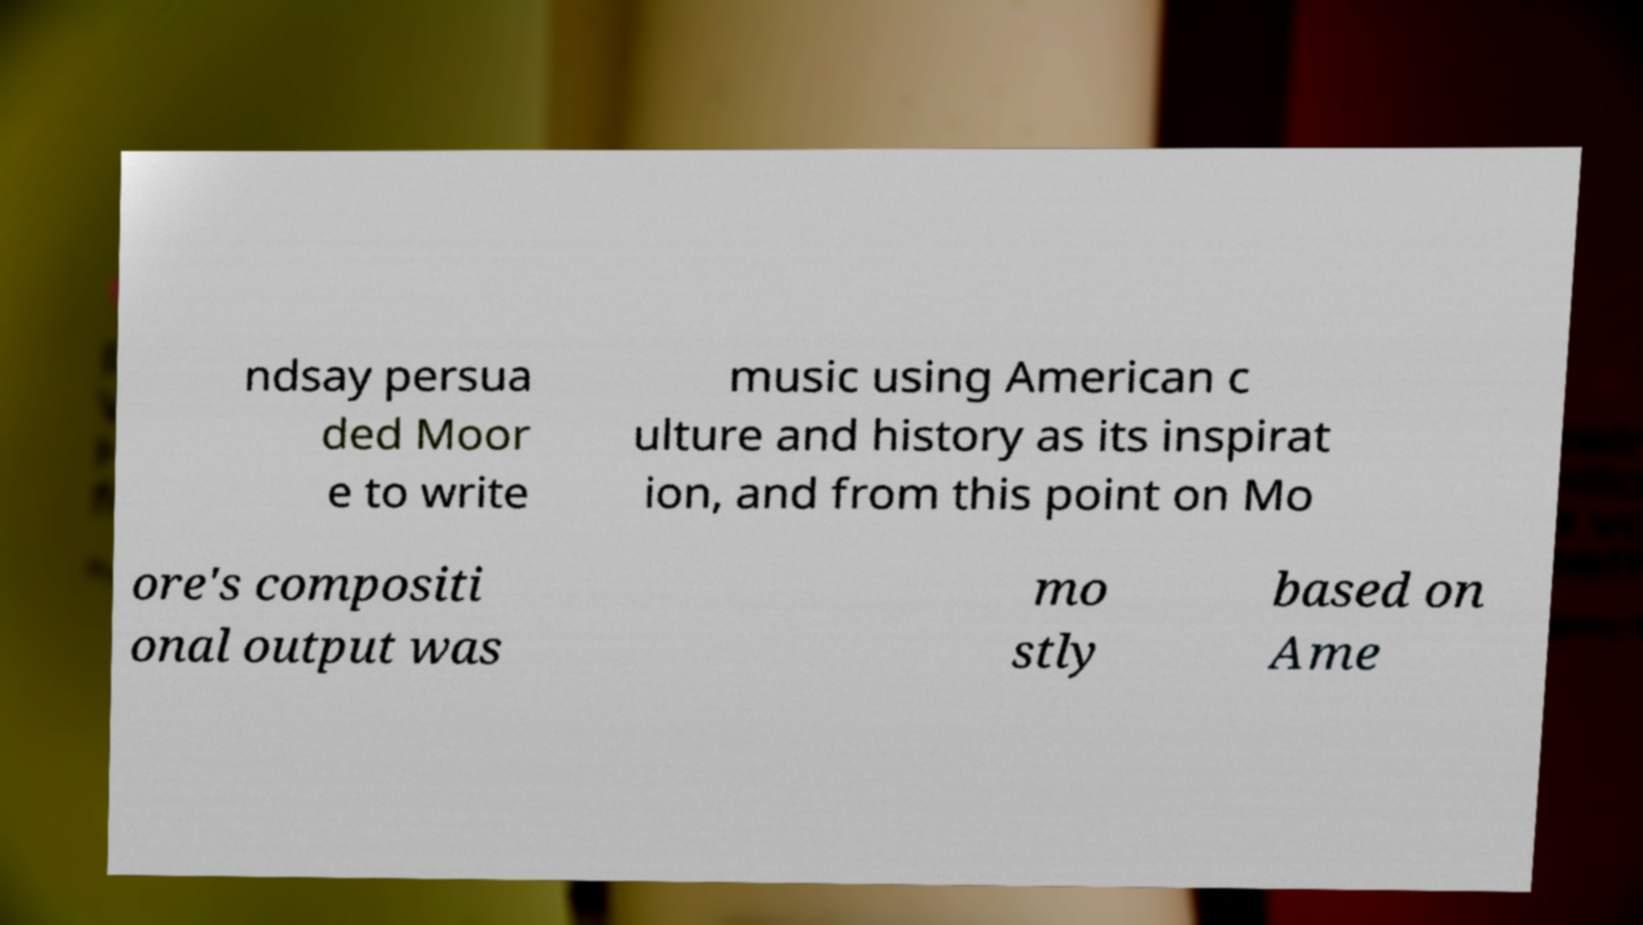Could you assist in decoding the text presented in this image and type it out clearly? ndsay persua ded Moor e to write music using American c ulture and history as its inspirat ion, and from this point on Mo ore's compositi onal output was mo stly based on Ame 